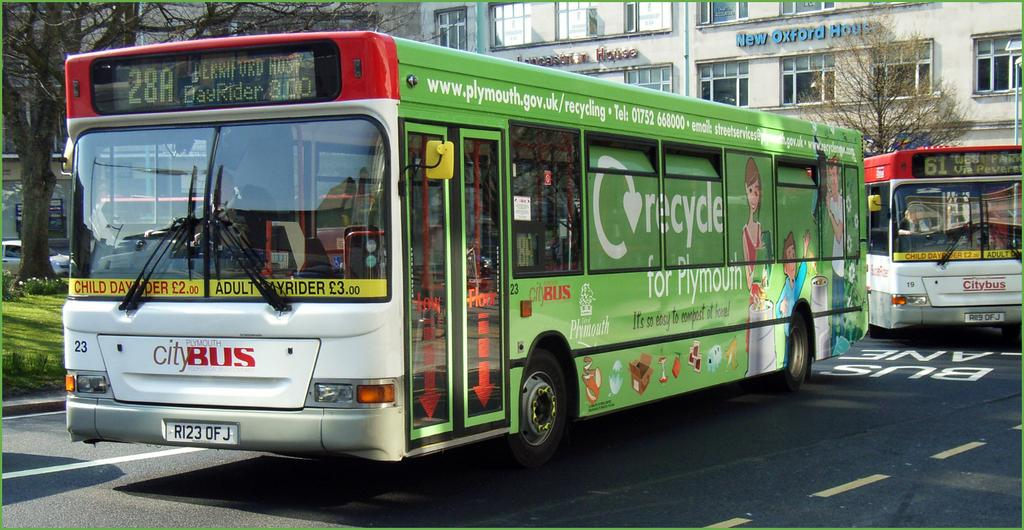What type of vehicles can be seen on the road in the image? There are buses on the road in the image. What can be seen in the background of the image? There are trees, buildings, and grass in the background of the image. What type of stone is used to build the range in the image? There is no range or stone present in the image. The image features buses on the road and trees, buildings, and grass in the background. 